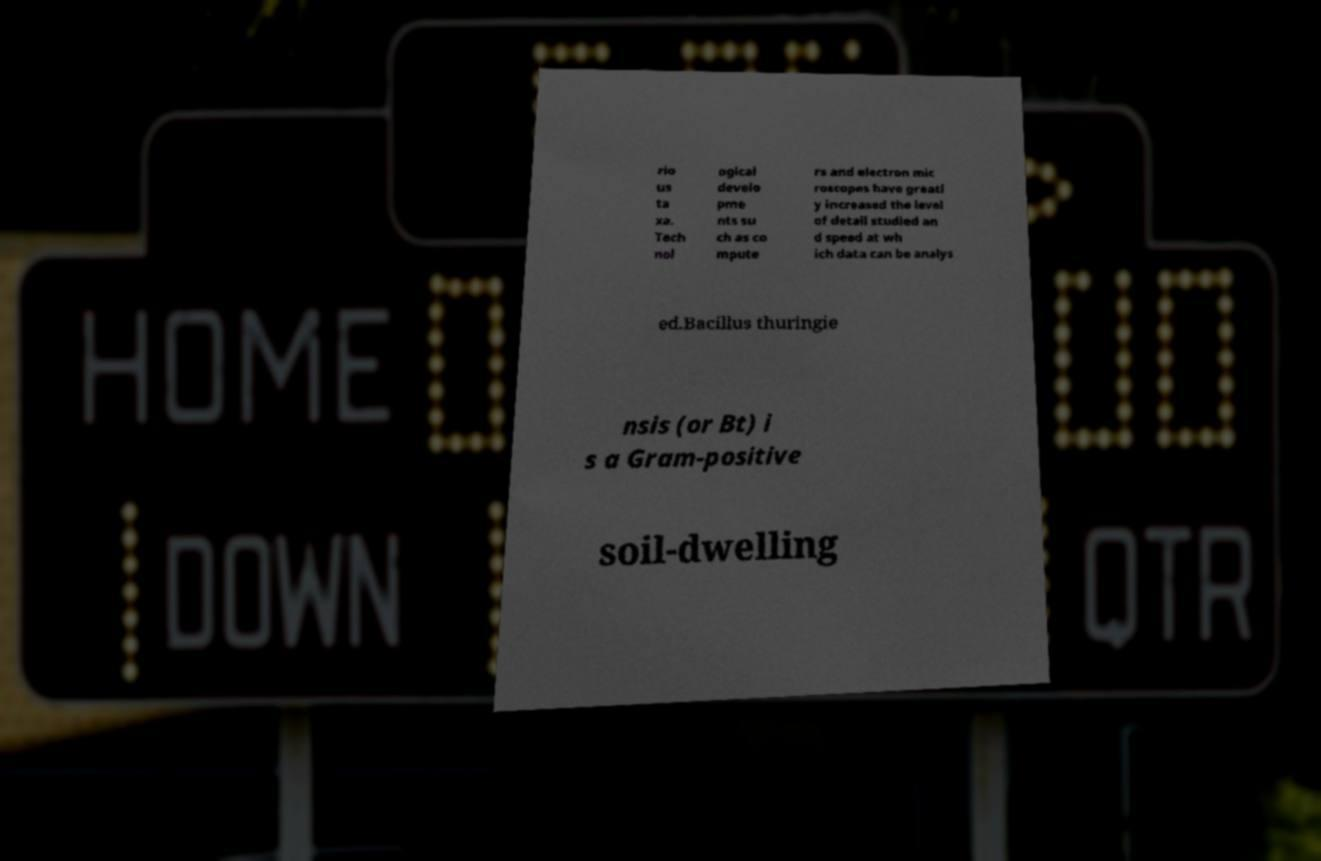Can you read and provide the text displayed in the image?This photo seems to have some interesting text. Can you extract and type it out for me? rio us ta xa. Tech nol ogical develo pme nts su ch as co mpute rs and electron mic roscopes have greatl y increased the level of detail studied an d speed at wh ich data can be analys ed.Bacillus thuringie nsis (or Bt) i s a Gram-positive soil-dwelling 